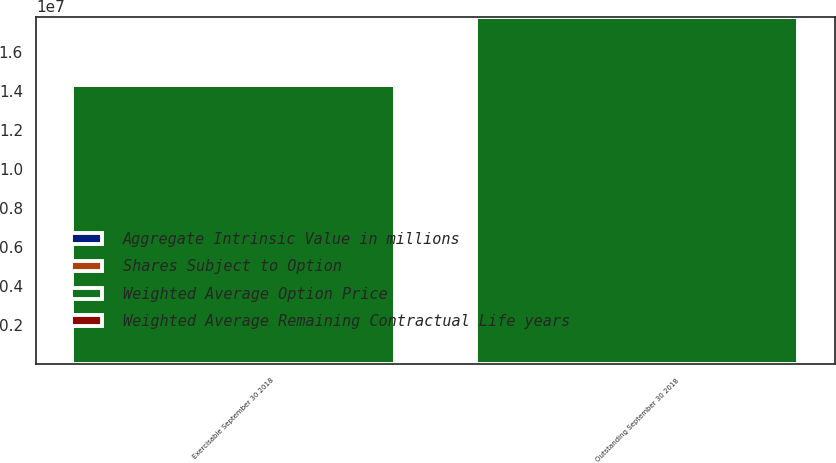Convert chart. <chart><loc_0><loc_0><loc_500><loc_500><stacked_bar_chart><ecel><fcel>Outstanding September 30 2018<fcel>Exercisable September 30 2018<nl><fcel>Weighted Average Remaining Contractual Life years<fcel>34.24<fcel>31.22<nl><fcel>Weighted Average Option Price<fcel>1.78361e+07<fcel>1.43292e+07<nl><fcel>Aggregate Intrinsic Value in millions<fcel>4.2<fcel>3.3<nl><fcel>Shares Subject to Option<fcel>84<fcel>84<nl></chart> 